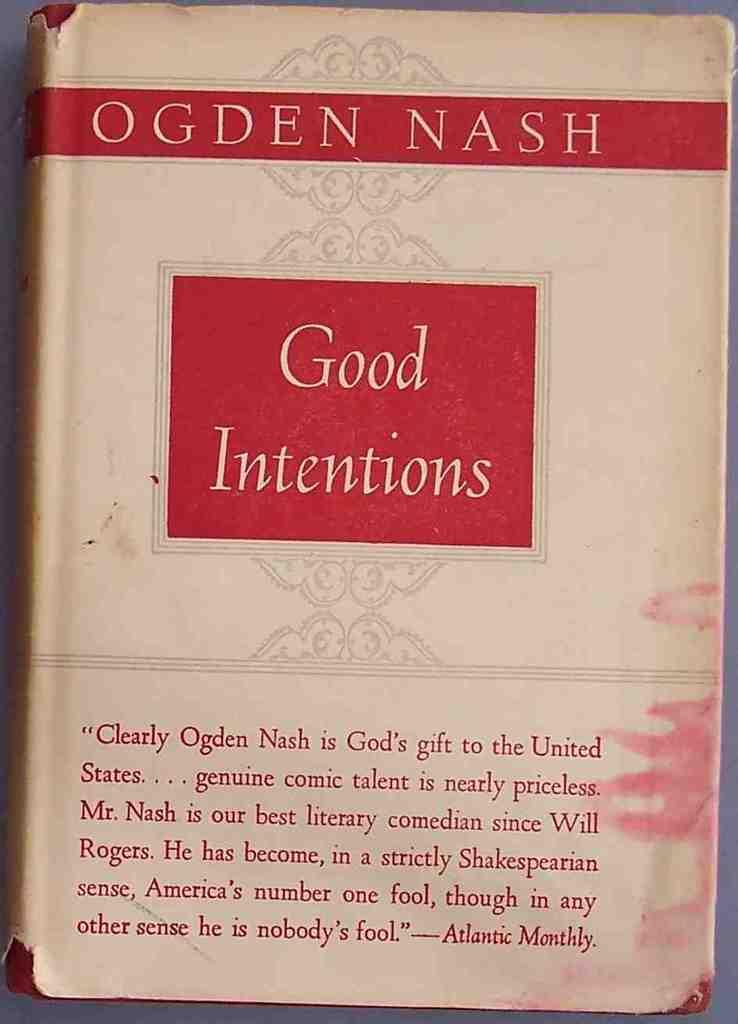<image>
Write a terse but informative summary of the picture. a book cover titled ' good intentions' by ogden nash 